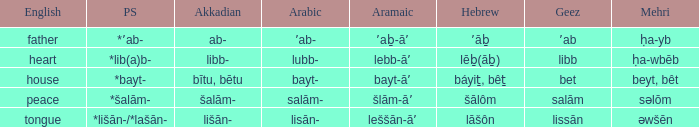If the proto-semitic is *bayt-, what are the geez? Bet. Help me parse the entirety of this table. {'header': ['English', 'PS', 'Akkadian', 'Arabic', 'Aramaic', 'Hebrew', 'Geez', 'Mehri'], 'rows': [['father', '*ʼab-', 'ab-', 'ʼab-', 'ʼaḇ-āʼ', 'ʼāḇ', 'ʼab', 'ḥa-yb'], ['heart', '*lib(a)b-', 'libb-', 'lubb-', 'lebb-āʼ', 'lēḇ(āḇ)', 'libb', 'ḥa-wbēb'], ['house', '*bayt-', 'bītu, bētu', 'bayt-', 'bayt-āʼ', 'báyiṯ, bêṯ', 'bet', 'beyt, bêt'], ['peace', '*šalām-', 'šalām-', 'salām-', 'šlām-āʼ', 'šālôm', 'salām', 'səlōm'], ['tongue', '*lišān-/*lašān-', 'lišān-', 'lisān-', 'leššān-āʼ', 'lāšôn', 'lissān', 'əwšēn']]} 